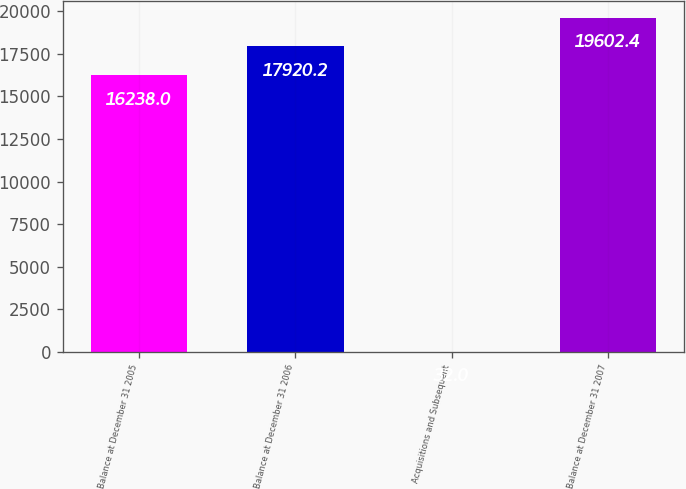Convert chart to OTSL. <chart><loc_0><loc_0><loc_500><loc_500><bar_chart><fcel>Balance at December 31 2005<fcel>Balance at December 31 2006<fcel>Acquisitions and Subsequent<fcel>Balance at December 31 2007<nl><fcel>16238<fcel>17920.2<fcel>32<fcel>19602.4<nl></chart> 